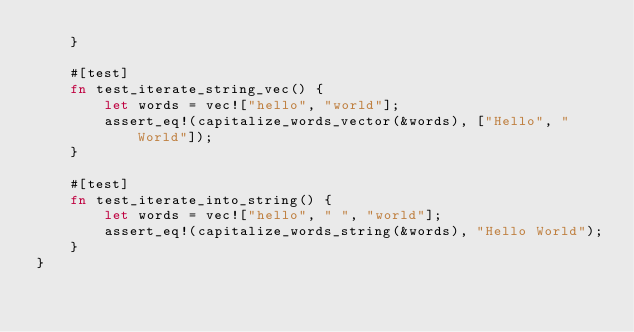Convert code to text. <code><loc_0><loc_0><loc_500><loc_500><_Rust_>    }

    #[test]
    fn test_iterate_string_vec() {
        let words = vec!["hello", "world"];
        assert_eq!(capitalize_words_vector(&words), ["Hello", "World"]);
    }

    #[test]
    fn test_iterate_into_string() {
        let words = vec!["hello", " ", "world"];
        assert_eq!(capitalize_words_string(&words), "Hello World");
    }
}
</code> 